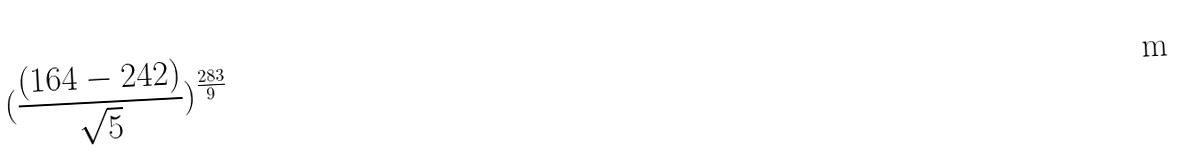Convert formula to latex. <formula><loc_0><loc_0><loc_500><loc_500>( \frac { ( 1 6 4 - 2 4 2 ) } { \sqrt { 5 } } ) ^ { \frac { 2 8 3 } { 9 } }</formula> 